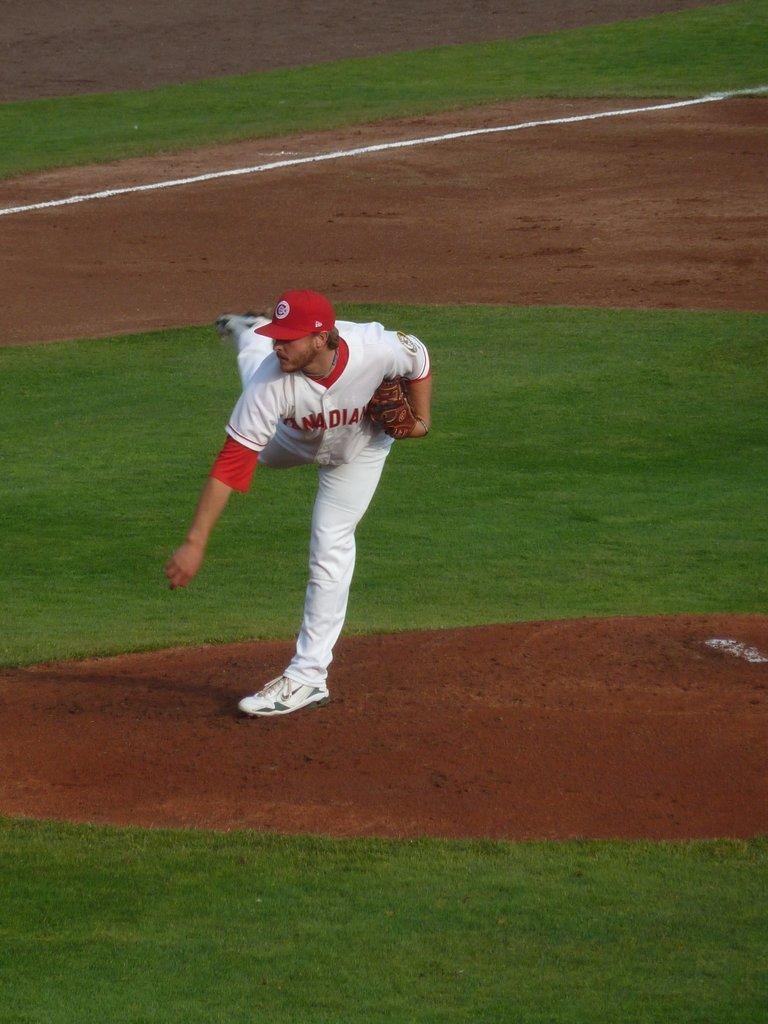<image>
Write a terse but informative summary of the picture. A player for the Canadians throws a pitch. 